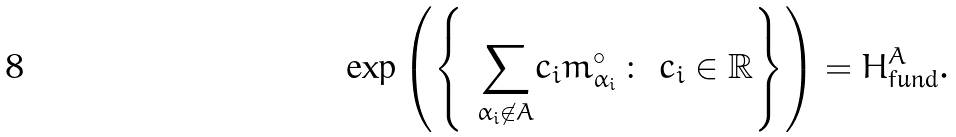<formula> <loc_0><loc_0><loc_500><loc_500>\exp \left ( \left \{ \ \underset { \alpha _ { i } \not \in A } { \sum } c _ { i } m _ { \alpha _ { i } } ^ { \circ } \, \colon \ c _ { i } \in { \mathbb { R } } \right \} \right ) = H ^ { A } _ { \text {fund} } .</formula> 